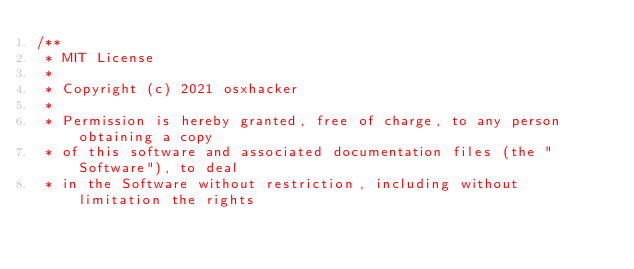Convert code to text. <code><loc_0><loc_0><loc_500><loc_500><_Scala_>/**
 * MIT License
 * 
 * Copyright (c) 2021 osxhacker
 * 
 * Permission is hereby granted, free of charge, to any person obtaining a copy
 * of this software and associated documentation files (the "Software"), to deal
 * in the Software without restriction, including without limitation the rights</code> 